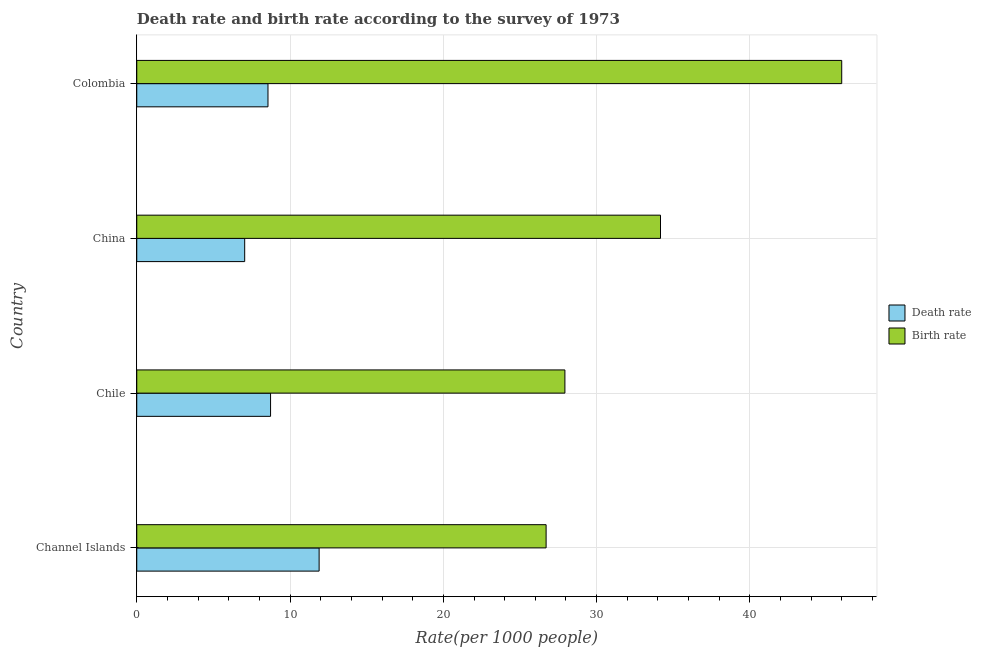How many bars are there on the 1st tick from the top?
Offer a very short reply. 2. What is the label of the 3rd group of bars from the top?
Your response must be concise. Chile. What is the death rate in Colombia?
Provide a succinct answer. 8.56. Across all countries, what is the maximum birth rate?
Your answer should be compact. 45.99. Across all countries, what is the minimum birth rate?
Ensure brevity in your answer.  26.7. In which country was the death rate maximum?
Offer a very short reply. Channel Islands. What is the total death rate in the graph?
Your response must be concise. 36.22. What is the difference between the birth rate in Chile and that in China?
Offer a terse response. -6.24. What is the difference between the death rate in China and the birth rate in Chile?
Your answer should be very brief. -20.89. What is the average birth rate per country?
Provide a short and direct response. 33.7. What is the difference between the death rate and birth rate in China?
Keep it short and to the point. -27.13. In how many countries, is the death rate greater than 32 ?
Provide a succinct answer. 0. What is the ratio of the death rate in Channel Islands to that in China?
Keep it short and to the point. 1.69. Is the death rate in Chile less than that in China?
Offer a very short reply. No. Is the difference between the death rate in China and Colombia greater than the difference between the birth rate in China and Colombia?
Offer a very short reply. Yes. What is the difference between the highest and the second highest death rate?
Offer a terse response. 3.17. What is the difference between the highest and the lowest death rate?
Your answer should be very brief. 4.86. Is the sum of the birth rate in Chile and China greater than the maximum death rate across all countries?
Your answer should be very brief. Yes. What does the 2nd bar from the top in Colombia represents?
Provide a succinct answer. Death rate. What does the 2nd bar from the bottom in China represents?
Your answer should be compact. Birth rate. Are all the bars in the graph horizontal?
Your answer should be compact. Yes. How many countries are there in the graph?
Ensure brevity in your answer.  4. What is the difference between two consecutive major ticks on the X-axis?
Provide a succinct answer. 10. Are the values on the major ticks of X-axis written in scientific E-notation?
Your answer should be very brief. No. Where does the legend appear in the graph?
Your response must be concise. Center right. How many legend labels are there?
Provide a short and direct response. 2. How are the legend labels stacked?
Provide a succinct answer. Vertical. What is the title of the graph?
Your answer should be very brief. Death rate and birth rate according to the survey of 1973. What is the label or title of the X-axis?
Give a very brief answer. Rate(per 1000 people). What is the label or title of the Y-axis?
Provide a succinct answer. Country. What is the Rate(per 1000 people) in Death rate in Channel Islands?
Your response must be concise. 11.9. What is the Rate(per 1000 people) of Birth rate in Channel Islands?
Give a very brief answer. 26.7. What is the Rate(per 1000 people) in Death rate in Chile?
Your answer should be compact. 8.73. What is the Rate(per 1000 people) of Birth rate in Chile?
Your answer should be very brief. 27.93. What is the Rate(per 1000 people) of Death rate in China?
Your answer should be compact. 7.04. What is the Rate(per 1000 people) of Birth rate in China?
Your answer should be compact. 34.17. What is the Rate(per 1000 people) in Death rate in Colombia?
Offer a very short reply. 8.56. What is the Rate(per 1000 people) of Birth rate in Colombia?
Offer a very short reply. 45.99. Across all countries, what is the maximum Rate(per 1000 people) in Death rate?
Offer a very short reply. 11.9. Across all countries, what is the maximum Rate(per 1000 people) of Birth rate?
Offer a very short reply. 45.99. Across all countries, what is the minimum Rate(per 1000 people) of Death rate?
Make the answer very short. 7.04. Across all countries, what is the minimum Rate(per 1000 people) in Birth rate?
Offer a terse response. 26.7. What is the total Rate(per 1000 people) in Death rate in the graph?
Provide a short and direct response. 36.22. What is the total Rate(per 1000 people) in Birth rate in the graph?
Offer a terse response. 134.79. What is the difference between the Rate(per 1000 people) in Death rate in Channel Islands and that in Chile?
Give a very brief answer. 3.17. What is the difference between the Rate(per 1000 people) in Birth rate in Channel Islands and that in Chile?
Make the answer very short. -1.23. What is the difference between the Rate(per 1000 people) in Death rate in Channel Islands and that in China?
Your response must be concise. 4.86. What is the difference between the Rate(per 1000 people) of Birth rate in Channel Islands and that in China?
Keep it short and to the point. -7.46. What is the difference between the Rate(per 1000 people) in Death rate in Channel Islands and that in Colombia?
Your answer should be very brief. 3.34. What is the difference between the Rate(per 1000 people) in Birth rate in Channel Islands and that in Colombia?
Provide a short and direct response. -19.28. What is the difference between the Rate(per 1000 people) of Death rate in Chile and that in China?
Your answer should be very brief. 1.69. What is the difference between the Rate(per 1000 people) of Birth rate in Chile and that in China?
Provide a succinct answer. -6.24. What is the difference between the Rate(per 1000 people) in Death rate in Chile and that in Colombia?
Offer a terse response. 0.17. What is the difference between the Rate(per 1000 people) in Birth rate in Chile and that in Colombia?
Make the answer very short. -18.06. What is the difference between the Rate(per 1000 people) of Death rate in China and that in Colombia?
Offer a very short reply. -1.52. What is the difference between the Rate(per 1000 people) of Birth rate in China and that in Colombia?
Your answer should be very brief. -11.82. What is the difference between the Rate(per 1000 people) of Death rate in Channel Islands and the Rate(per 1000 people) of Birth rate in Chile?
Keep it short and to the point. -16.03. What is the difference between the Rate(per 1000 people) in Death rate in Channel Islands and the Rate(per 1000 people) in Birth rate in China?
Your answer should be compact. -22.27. What is the difference between the Rate(per 1000 people) in Death rate in Channel Islands and the Rate(per 1000 people) in Birth rate in Colombia?
Provide a succinct answer. -34.09. What is the difference between the Rate(per 1000 people) in Death rate in Chile and the Rate(per 1000 people) in Birth rate in China?
Provide a succinct answer. -25.44. What is the difference between the Rate(per 1000 people) of Death rate in Chile and the Rate(per 1000 people) of Birth rate in Colombia?
Offer a very short reply. -37.26. What is the difference between the Rate(per 1000 people) in Death rate in China and the Rate(per 1000 people) in Birth rate in Colombia?
Your answer should be compact. -38.95. What is the average Rate(per 1000 people) of Death rate per country?
Your answer should be compact. 9.06. What is the average Rate(per 1000 people) of Birth rate per country?
Provide a short and direct response. 33.7. What is the difference between the Rate(per 1000 people) in Death rate and Rate(per 1000 people) in Birth rate in Channel Islands?
Your answer should be compact. -14.81. What is the difference between the Rate(per 1000 people) of Death rate and Rate(per 1000 people) of Birth rate in Chile?
Ensure brevity in your answer.  -19.2. What is the difference between the Rate(per 1000 people) in Death rate and Rate(per 1000 people) in Birth rate in China?
Give a very brief answer. -27.13. What is the difference between the Rate(per 1000 people) in Death rate and Rate(per 1000 people) in Birth rate in Colombia?
Give a very brief answer. -37.43. What is the ratio of the Rate(per 1000 people) of Death rate in Channel Islands to that in Chile?
Your answer should be very brief. 1.36. What is the ratio of the Rate(per 1000 people) of Birth rate in Channel Islands to that in Chile?
Provide a succinct answer. 0.96. What is the ratio of the Rate(per 1000 people) of Death rate in Channel Islands to that in China?
Give a very brief answer. 1.69. What is the ratio of the Rate(per 1000 people) of Birth rate in Channel Islands to that in China?
Provide a short and direct response. 0.78. What is the ratio of the Rate(per 1000 people) in Death rate in Channel Islands to that in Colombia?
Your answer should be compact. 1.39. What is the ratio of the Rate(per 1000 people) in Birth rate in Channel Islands to that in Colombia?
Keep it short and to the point. 0.58. What is the ratio of the Rate(per 1000 people) of Death rate in Chile to that in China?
Your answer should be compact. 1.24. What is the ratio of the Rate(per 1000 people) of Birth rate in Chile to that in China?
Provide a short and direct response. 0.82. What is the ratio of the Rate(per 1000 people) in Death rate in Chile to that in Colombia?
Offer a terse response. 1.02. What is the ratio of the Rate(per 1000 people) of Birth rate in Chile to that in Colombia?
Offer a terse response. 0.61. What is the ratio of the Rate(per 1000 people) in Death rate in China to that in Colombia?
Give a very brief answer. 0.82. What is the ratio of the Rate(per 1000 people) in Birth rate in China to that in Colombia?
Your response must be concise. 0.74. What is the difference between the highest and the second highest Rate(per 1000 people) of Death rate?
Make the answer very short. 3.17. What is the difference between the highest and the second highest Rate(per 1000 people) in Birth rate?
Offer a very short reply. 11.82. What is the difference between the highest and the lowest Rate(per 1000 people) in Death rate?
Ensure brevity in your answer.  4.86. What is the difference between the highest and the lowest Rate(per 1000 people) in Birth rate?
Give a very brief answer. 19.28. 